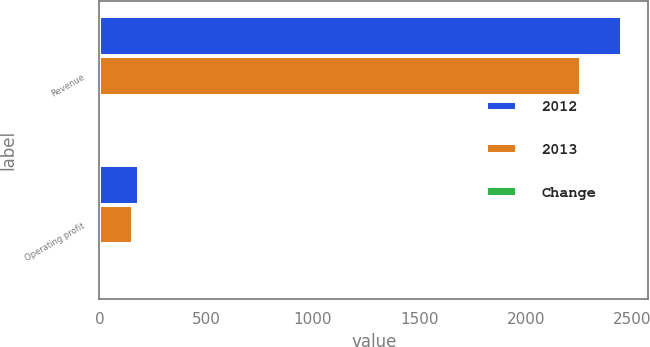<chart> <loc_0><loc_0><loc_500><loc_500><stacked_bar_chart><ecel><fcel>Revenue<fcel>Operating profit<nl><fcel>2012<fcel>2450<fcel>185<nl><fcel>2013<fcel>2257<fcel>158<nl><fcel>Change<fcel>9<fcel>17<nl></chart> 